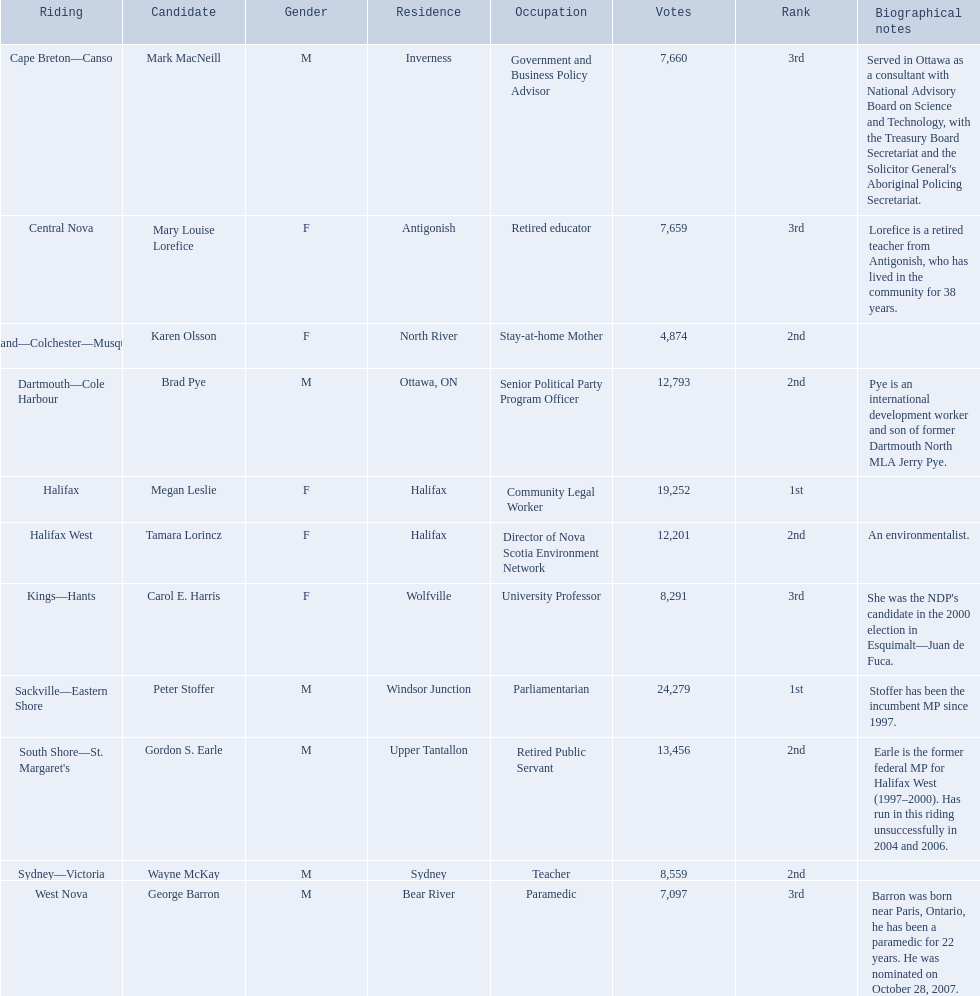What new democratic party candidates ran in the 2008 canadian federal election? Mark MacNeill, Mary Louise Lorefice, Karen Olsson, Brad Pye, Megan Leslie, Tamara Lorincz, Carol E. Harris, Peter Stoffer, Gordon S. Earle, Wayne McKay, George Barron. Of these candidates, which are female? Mary Louise Lorefice, Karen Olsson, Megan Leslie, Tamara Lorincz, Carol E. Harris. Which of these candidates resides in halifax? Megan Leslie, Tamara Lorincz. Of the remaining two, which was ranked 1st? Megan Leslie. How many votes did she get? 19,252. 